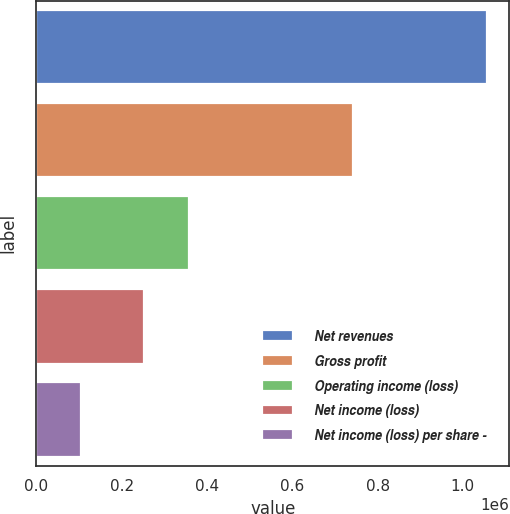Convert chart to OTSL. <chart><loc_0><loc_0><loc_500><loc_500><bar_chart><fcel>Net revenues<fcel>Gross profit<fcel>Operating income (loss)<fcel>Net income (loss)<fcel>Net income (loss) per share -<nl><fcel>1.05586e+06<fcel>742422<fcel>356914<fcel>251328<fcel>105587<nl></chart> 